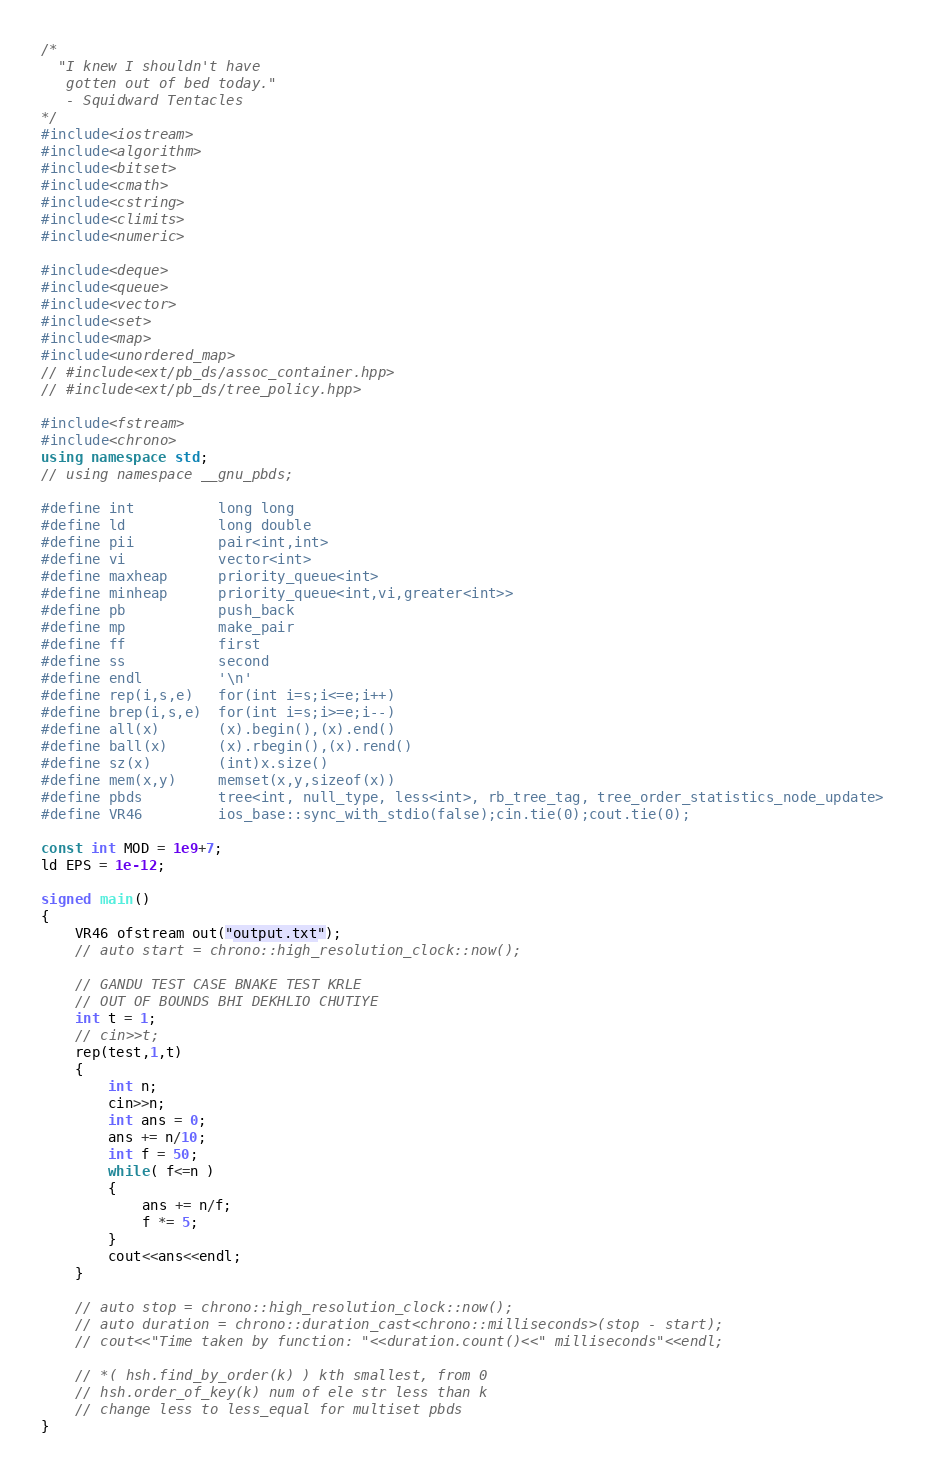Convert code to text. <code><loc_0><loc_0><loc_500><loc_500><_C++_>/*
  "I knew I shouldn't have
   gotten out of bed today."
   - Squidward Tentacles
*/
#include<iostream>
#include<algorithm>
#include<bitset>
#include<cmath>
#include<cstring>
#include<climits>
#include<numeric>

#include<deque>
#include<queue>
#include<vector>
#include<set>
#include<map>
#include<unordered_map>
// #include<ext/pb_ds/assoc_container.hpp>
// #include<ext/pb_ds/tree_policy.hpp>

#include<fstream>
#include<chrono>
using namespace std;
// using namespace __gnu_pbds;

#define int          long long
#define ld           long double
#define pii          pair<int,int>
#define vi           vector<int>
#define maxheap      priority_queue<int>
#define minheap      priority_queue<int,vi,greater<int>>
#define pb           push_back
#define mp           make_pair
#define ff           first
#define ss           second
#define endl         '\n'
#define rep(i,s,e)   for(int i=s;i<=e;i++)
#define brep(i,s,e)  for(int i=s;i>=e;i--)
#define all(x)       (x).begin(),(x).end()
#define ball(x)      (x).rbegin(),(x).rend()
#define sz(x)        (int)x.size()
#define mem(x,y)     memset(x,y,sizeof(x))
#define pbds         tree<int, null_type, less<int>, rb_tree_tag, tree_order_statistics_node_update>
#define VR46         ios_base::sync_with_stdio(false);cin.tie(0);cout.tie(0);

const int MOD = 1e9+7;
ld EPS = 1e-12;

signed main()
{
    VR46 ofstream out("output.txt");
    // auto start = chrono::high_resolution_clock::now();

    // GANDU TEST CASE BNAKE TEST KRLE
    // OUT OF BOUNDS BHI DEKHLIO CHUTIYE
    int t = 1;
    // cin>>t;
    rep(test,1,t)
    {
        int n;
        cin>>n;
        int ans = 0;
        ans += n/10;
        int f = 50;
        while( f<=n )
        {
            ans += n/f;
            f *= 5;
        }
        cout<<ans<<endl;
    }

    // auto stop = chrono::high_resolution_clock::now();
    // auto duration = chrono::duration_cast<chrono::milliseconds>(stop - start); 
    // cout<<"Time taken by function: "<<duration.count()<<" milliseconds"<<endl;

    // *( hsh.find_by_order(k) ) kth smallest, from 0
    // hsh.order_of_key(k) num of ele str less than k
    // change less to less_equal for multiset pbds
}</code> 